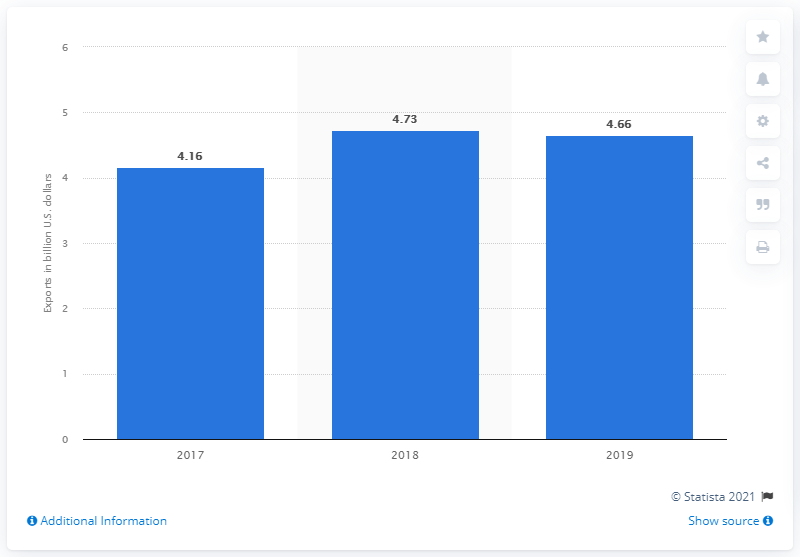Mention a couple of crucial points in this snapshot. In 2019, the value of salmon exports from Chile to the United States was approximately 4.66 billion dollars. Chile's salmon exports were 4.73 million units a year earlier. 